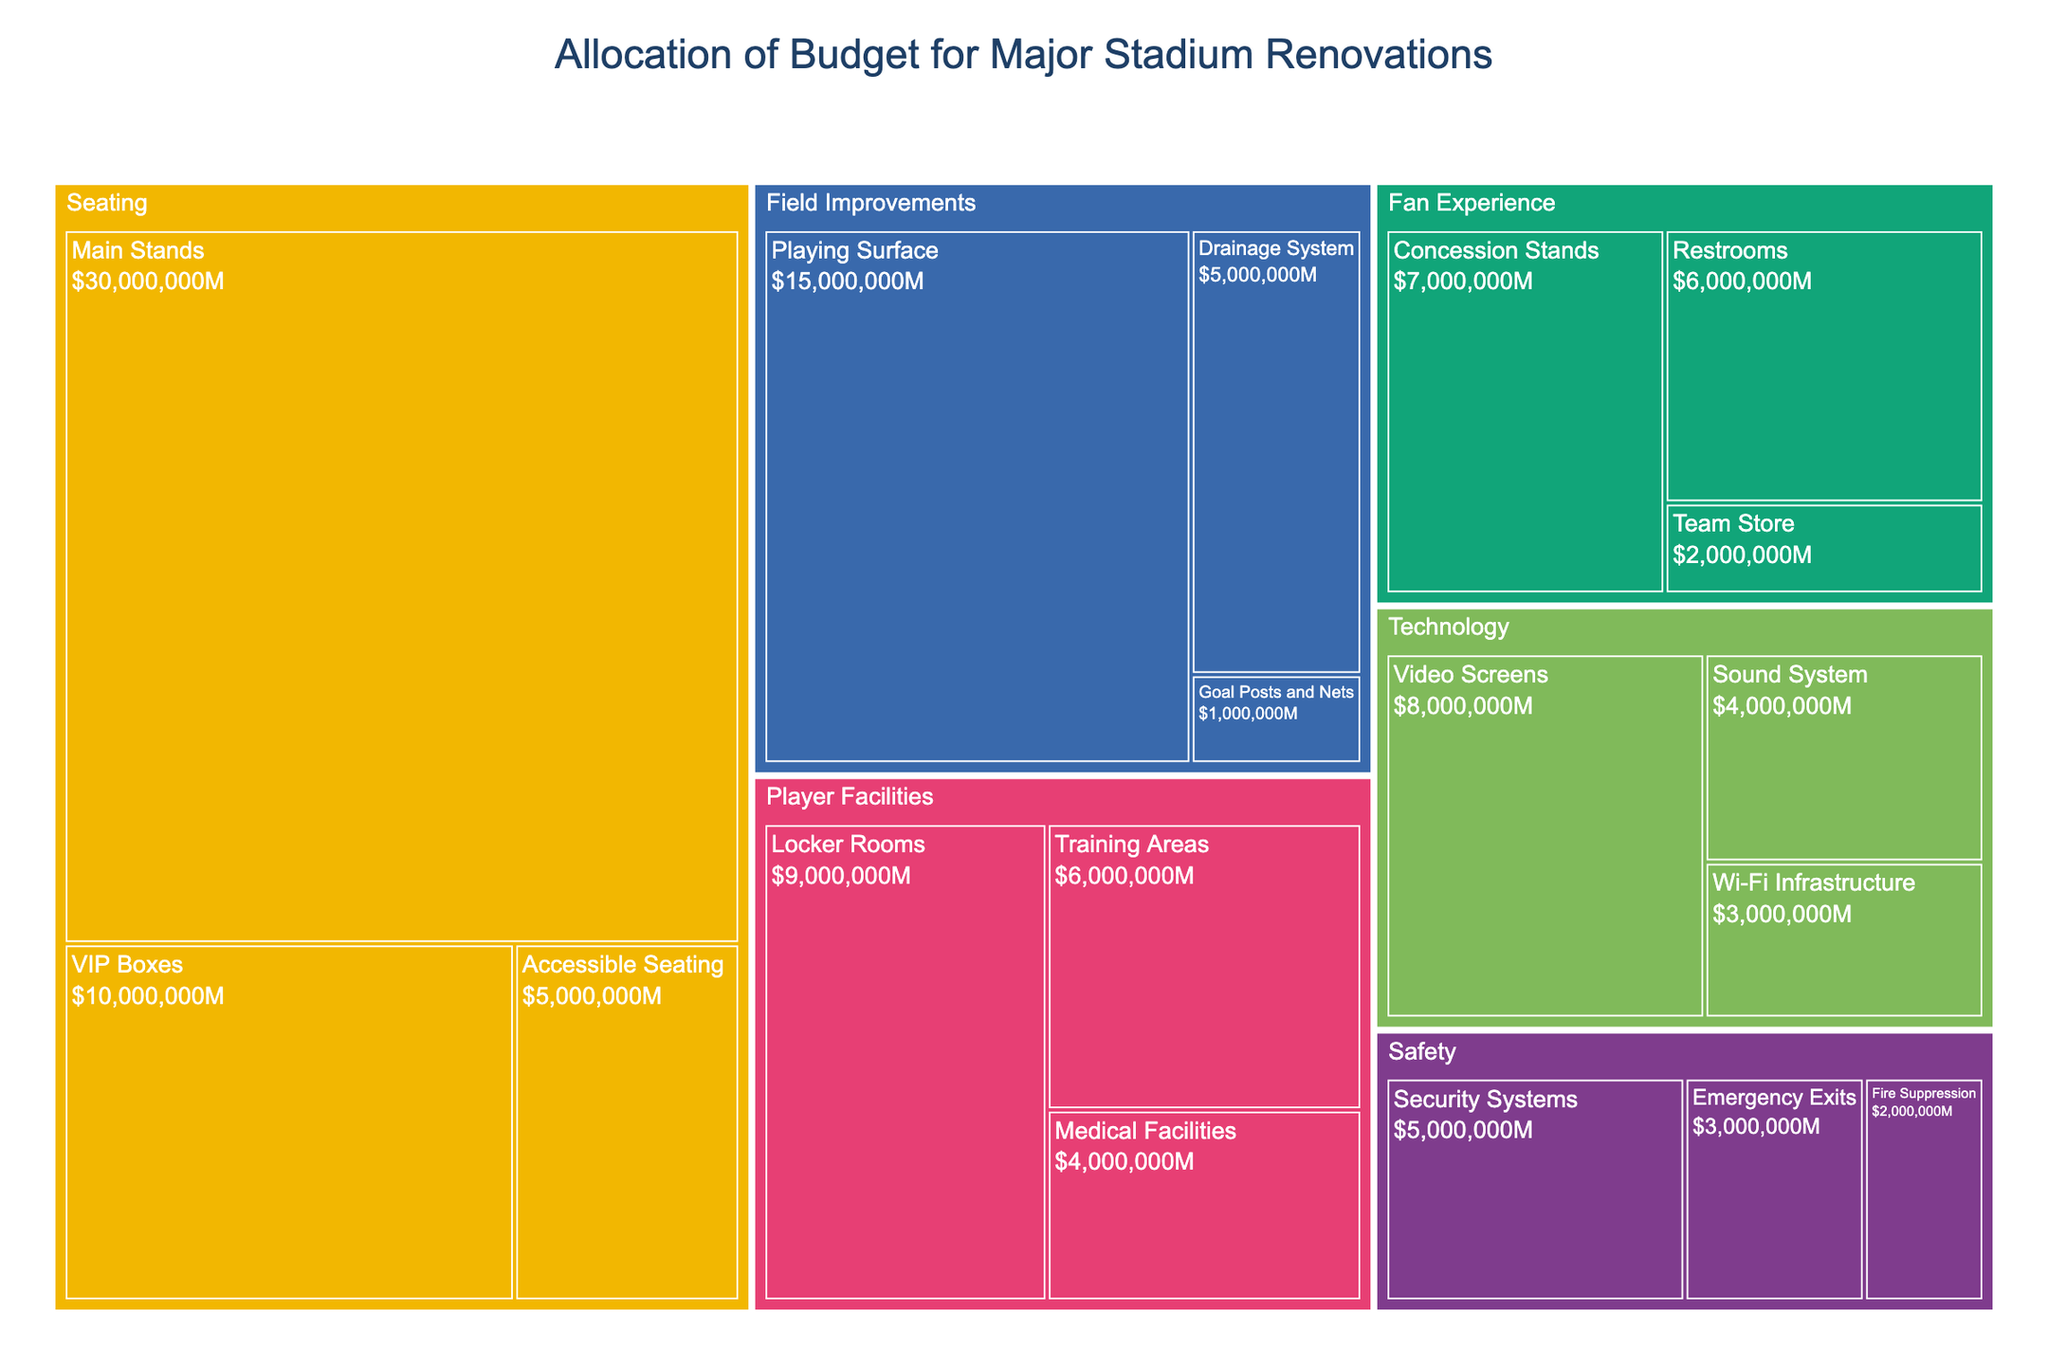What is the total budget allocated for Field Improvements? From the treemap, add up the budgets allocated for Playing Surface ($15,000,000), Drainage System ($5,000,000), and Goal Posts and Nets ($1,000,000). The total is $15,000,000 + $5,000,000 + $1,000,000 = $21,000,000.
Answer: $21,000,000 Which area received the highest budget allocation, and how much was it? Observe the sizes of the sections in the treemap. The Main Stands under Seating received the highest budget allocation at $30,000,000, which is the largest segment visible in the plot.
Answer: Seating (Main Stands), $30,000,000 How much more budget is allocated to VIP Boxes compared to Concession Stands? The budget for VIP Boxes is $10,000,000, and for Concession Stands, it is $7,000,000. Calculate the difference: $10,000,000 - $7,000,000 = $3,000,000.
Answer: $3,000,000 Which category within Technology has the lowest budget allocation? In the Technology section of the treemap, compare the budgets for Video Screens ($8,000,000), Sound System ($4,000,000), and Wi-Fi Infrastructure ($3,000,000). The Wi-Fi Infrastructure has the lowest allocation.
Answer: Wi-Fi Infrastructure What is the combined budget for Player Facilities and Safety? Sum the budget allocations for Player Facilities (Locker Rooms $9,000,000 + Training Areas $6,000,000 + Medical Facilities $4,000,000) and Safety (Security Systems $5,000,000 + Emergency Exits $3,000,000 + Fire Suppression $2,000,000). This yields ($9,000,000 + $6,000,000 + $4,000,000) + ($5,000,000 + $3,000,000 + $2,000,000) = $19,000,000 + $10,000,000 = $29,000,000.
Answer: $29,000,000 Which two categories combined make up the highest portion of the budget? From the treemap, add up the budgets of the top sections. The highest combined will be Main Stands under Seating ($30,000,000) and Playing Surface under Field Improvements ($15,000,000). Together, they total $30,000,000 + $15,000,000 = $45,000,000.
Answer: Main Stands and Playing Surface, $45,000,000 How does the budget allocation for Emergency Exits compare to the budget for Accessible Seating? The budget for Emergency Exits is $3,000,000, and for Accessible Seating, it is $5,000,000. Emergency Exits receive less than Accessible Seating.
Answer: Less What is the average budget for all categories under Fan Experience? Sum up the budgets for Concession Stands ($7,000,000), Restrooms ($6,000,000), and Team Store ($2,000,000), then divide by the number of categories. The total budget is $7,000,000 + $6,000,000 + $2,000,000 = $15,000,000, and the number of categories is 3. The average is $15,000,000 / 3 = $5,000,000.
Answer: $5,000,000 